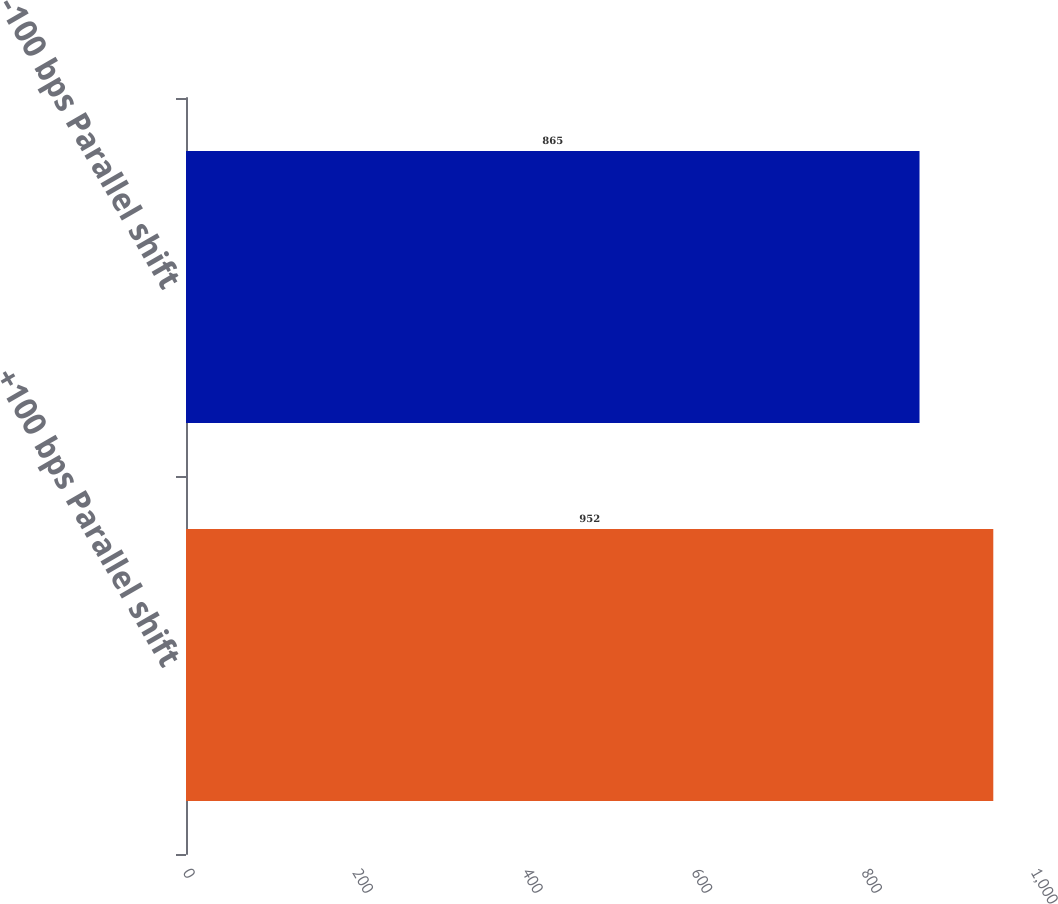<chart> <loc_0><loc_0><loc_500><loc_500><bar_chart><fcel>+100 bps Parallel shift<fcel>-100 bps Parallel shift<nl><fcel>952<fcel>865<nl></chart> 